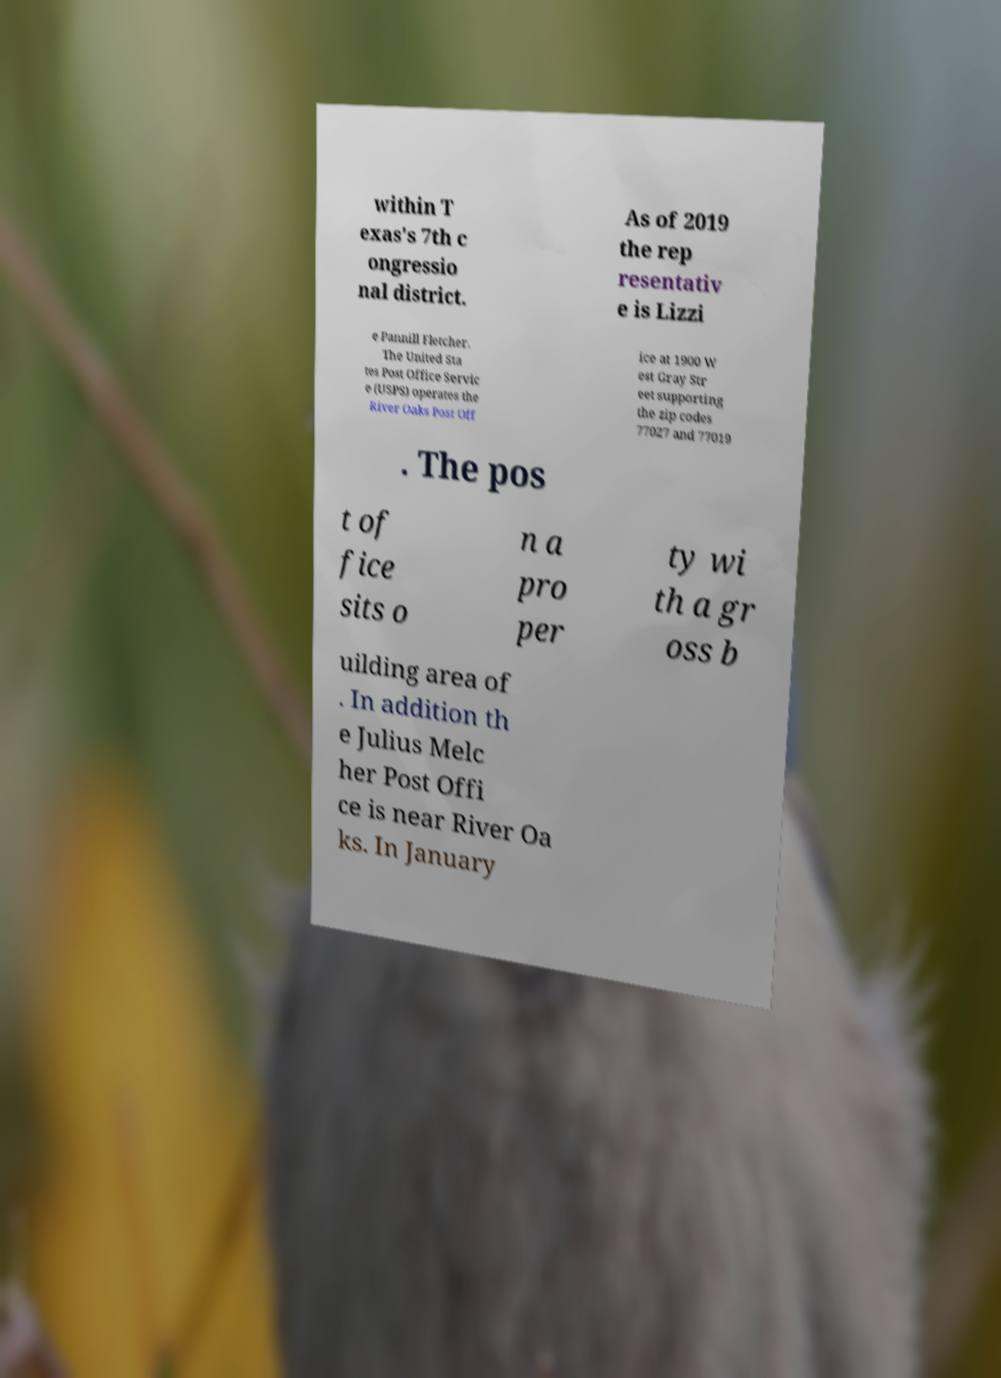Please identify and transcribe the text found in this image. within T exas's 7th c ongressio nal district. As of 2019 the rep resentativ e is Lizzi e Pannill Fletcher. The United Sta tes Post Office Servic e (USPS) operates the River Oaks Post Off ice at 1900 W est Gray Str eet supporting the zip codes 77027 and 77019 . The pos t of fice sits o n a pro per ty wi th a gr oss b uilding area of . In addition th e Julius Melc her Post Offi ce is near River Oa ks. In January 